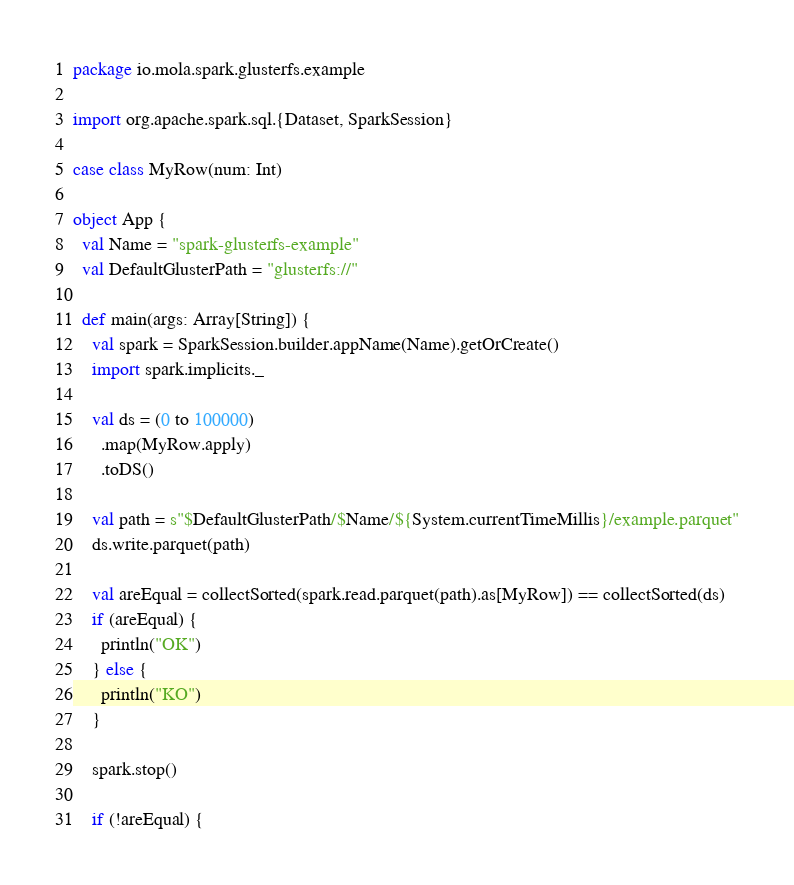<code> <loc_0><loc_0><loc_500><loc_500><_Scala_>package io.mola.spark.glusterfs.example

import org.apache.spark.sql.{Dataset, SparkSession}

case class MyRow(num: Int)

object App {
  val Name = "spark-glusterfs-example"
  val DefaultGlusterPath = "glusterfs://"

  def main(args: Array[String]) {
    val spark = SparkSession.builder.appName(Name).getOrCreate()
    import spark.implicits._

    val ds = (0 to 100000)
      .map(MyRow.apply)
      .toDS()

    val path = s"$DefaultGlusterPath/$Name/${System.currentTimeMillis}/example.parquet"
    ds.write.parquet(path)

    val areEqual = collectSorted(spark.read.parquet(path).as[MyRow]) == collectSorted(ds)
    if (areEqual) {
      println("OK")
    } else {
      println("KO")
    }

    spark.stop()

    if (!areEqual) {</code> 